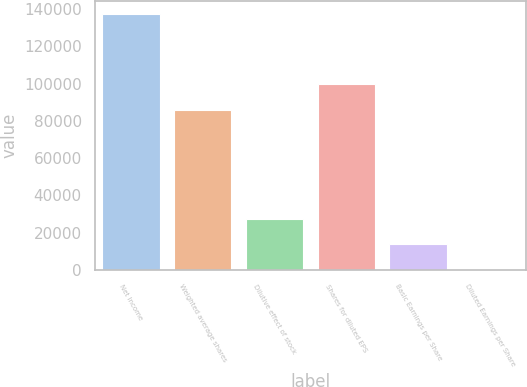<chart> <loc_0><loc_0><loc_500><loc_500><bar_chart><fcel>Net Income<fcel>Weighted average shares<fcel>Dilutive effect of stock<fcel>Shares for diluted EPS<fcel>Basic Earnings per Share<fcel>Diluted Earnings per Share<nl><fcel>137471<fcel>85948<fcel>27495.5<fcel>99694.9<fcel>13748.5<fcel>1.59<nl></chart> 